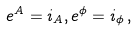Convert formula to latex. <formula><loc_0><loc_0><loc_500><loc_500>e ^ { A } = i _ { A } , e ^ { \phi } = i _ { \phi } \, ,</formula> 